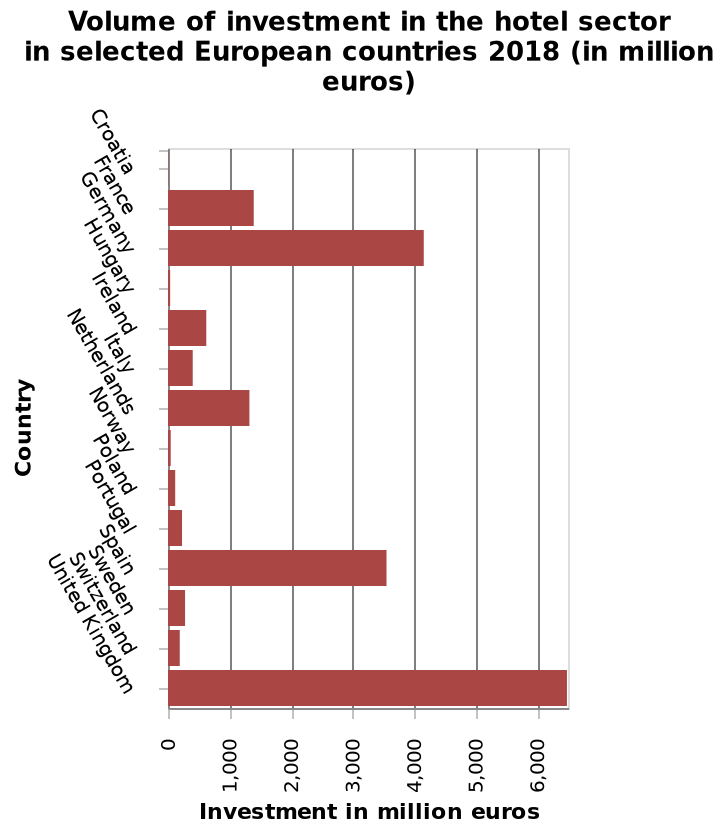<image>
How is the country variable measured on the y-axis? The country variable is measured as a categorical scale on the y-axis, starting at Croatia and ending at an unspecified country. 